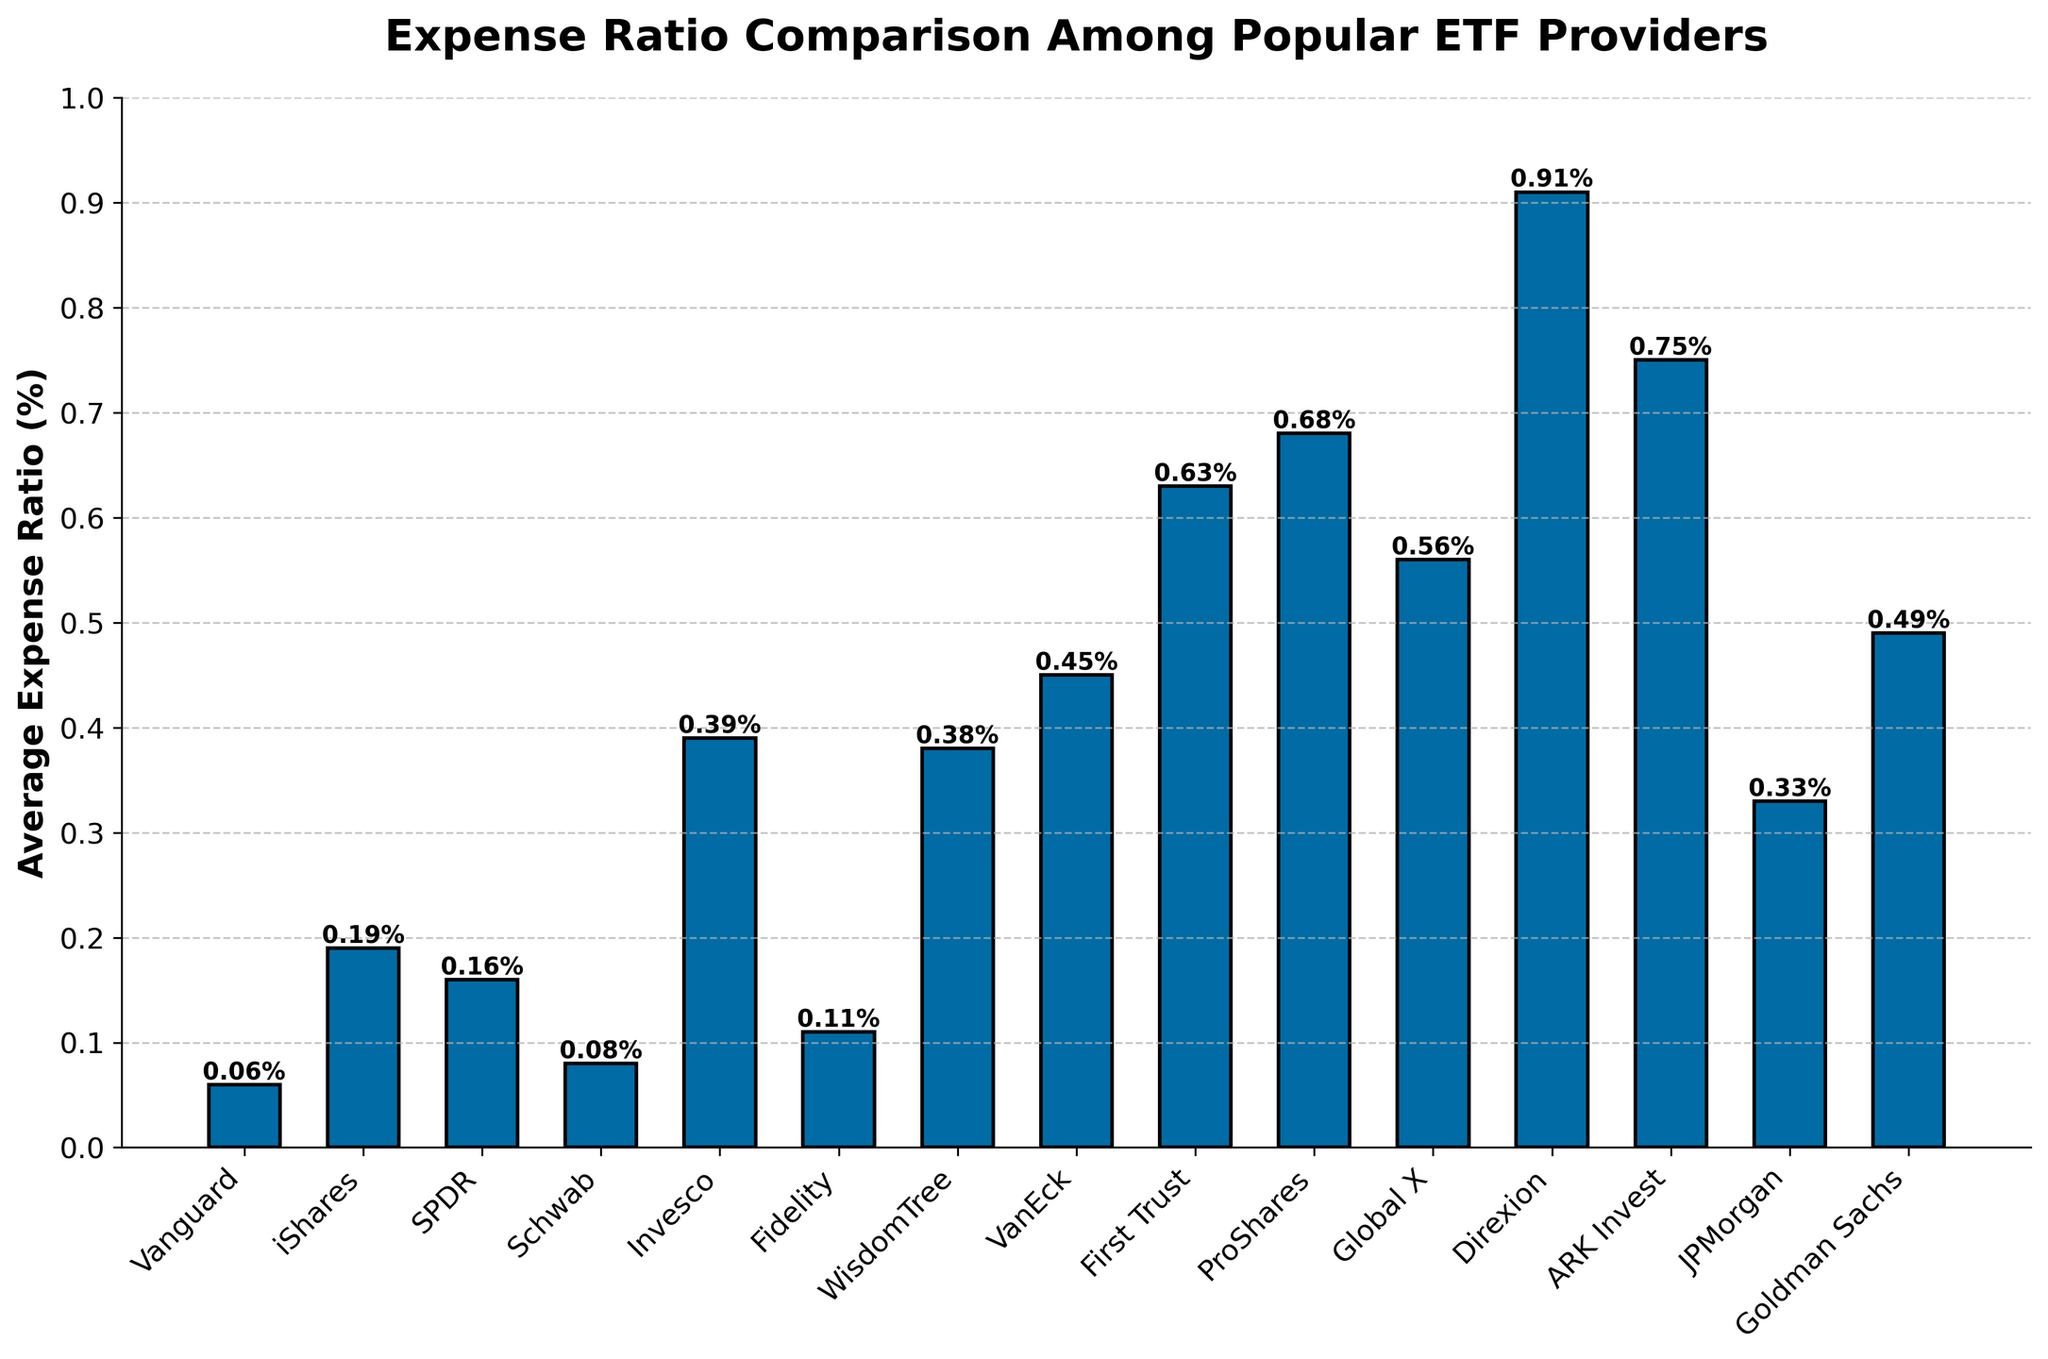What is the average expense ratio of the ETF providers with the lowest and highest expense ratios? The lowest expense ratio is 0.06% (Vanguard) and the highest is 0.91% (Direxion). The average of these two values is \( (0.06 + 0.91) / 2 = 0.485\% \)
Answer: 0.485% Which ETF provider has the second highest expense ratio? By observing the height of the bars, the highest is Direxion with 0.91%, and the second highest is ARK Invest with 0.75%
Answer: ARK Invest How does the expense ratio of Vanguard compare to that of iShares? Vanguard's expense ratio is 0.06%, while iShares' expense ratio is 0.19%. The difference is \( 0.19\% - 0.06\% = 0.13\% \)
Answer: 0.13% lower What is the combined average expense ratio for Vanguard, Schwab, and Fidelity? Adding the expense ratios of Vanguard (0.06%), Schwab (0.08%), and Fidelity (0.11%) gives \( 0.06 + 0.08 + 0.11 = 0.25 \). The average is then \( 0.25 / 3 = 0.083\% \)
Answer: 0.083% Which ETF provider has an expense ratio closest to 0.5%? By observing the heights of the bars, Goldman Sachs has an expense ratio of 0.49%, which is closest to 0.5%.
Answer: Goldman Sachs What is the difference in expense ratio between the highest and lowest ETF providers? The highest expense ratio is 0.91% (Direxion) and the lowest is 0.06% (Vanguard). The difference is \( 0.91\% - 0.06\% = 0.85\% \)
Answer: 0.85% Rank the top three ETF providers with the lowest expense ratios. The bars representing the expense ratios of each provider show that the lowest three are Vanguard (0.06%), Schwab (0.08%), and Fidelity (0.11%)
Answer: Vanguard, Schwab, Fidelity Is the expense ratio of ProShares higher or lower than the average expense ratio of all listed ETF providers? To find the average expense ratio of all providers, sum all the expense ratios and divide by the number of providers. The total sum is \( 0.06 + 0.19 + 0.16 + 0.08 + 0.39 + 0.11 + 0.38 + 0.45 + 0.63 + 0.68 + 0.56 + 0.91 + 0.75 + 0.33 + 0.49 = 6.17 \). There are 15 providers, so the average is \( 6.17 / 15 = 0.411\% \). ProShares has an expense ratio of 0.68%, which is higher.
Answer: Higher Compare the expense ratio of Schwab and SPDR. Which one is higher and by how much? Schwab has an expense ratio of 0.08%, while SPDR's expense ratio is 0.16%. The difference is \( 0.16\% - 0.08\% = 0.08\% \). SPDR is higher by 0.08%.
Answer: SPDR by 0.08% 